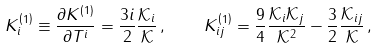<formula> <loc_0><loc_0><loc_500><loc_500>K ^ { \left ( 1 \right ) } _ { i } \equiv \frac { \partial K ^ { \left ( 1 \right ) } } { \partial T ^ { i } } = \frac { 3 i } { 2 } \frac { \mathcal { K } _ { i } } { \mathcal { K } } \, , \quad K ^ { \left ( 1 \right ) } _ { i j } = \frac { 9 } { 4 } \frac { \mathcal { K } _ { i } \mathcal { K } _ { j } } { \mathcal { K } ^ { 2 } } - \frac { 3 } { 2 } \frac { \mathcal { K } _ { i j } } { \mathcal { K } } \, ,</formula> 